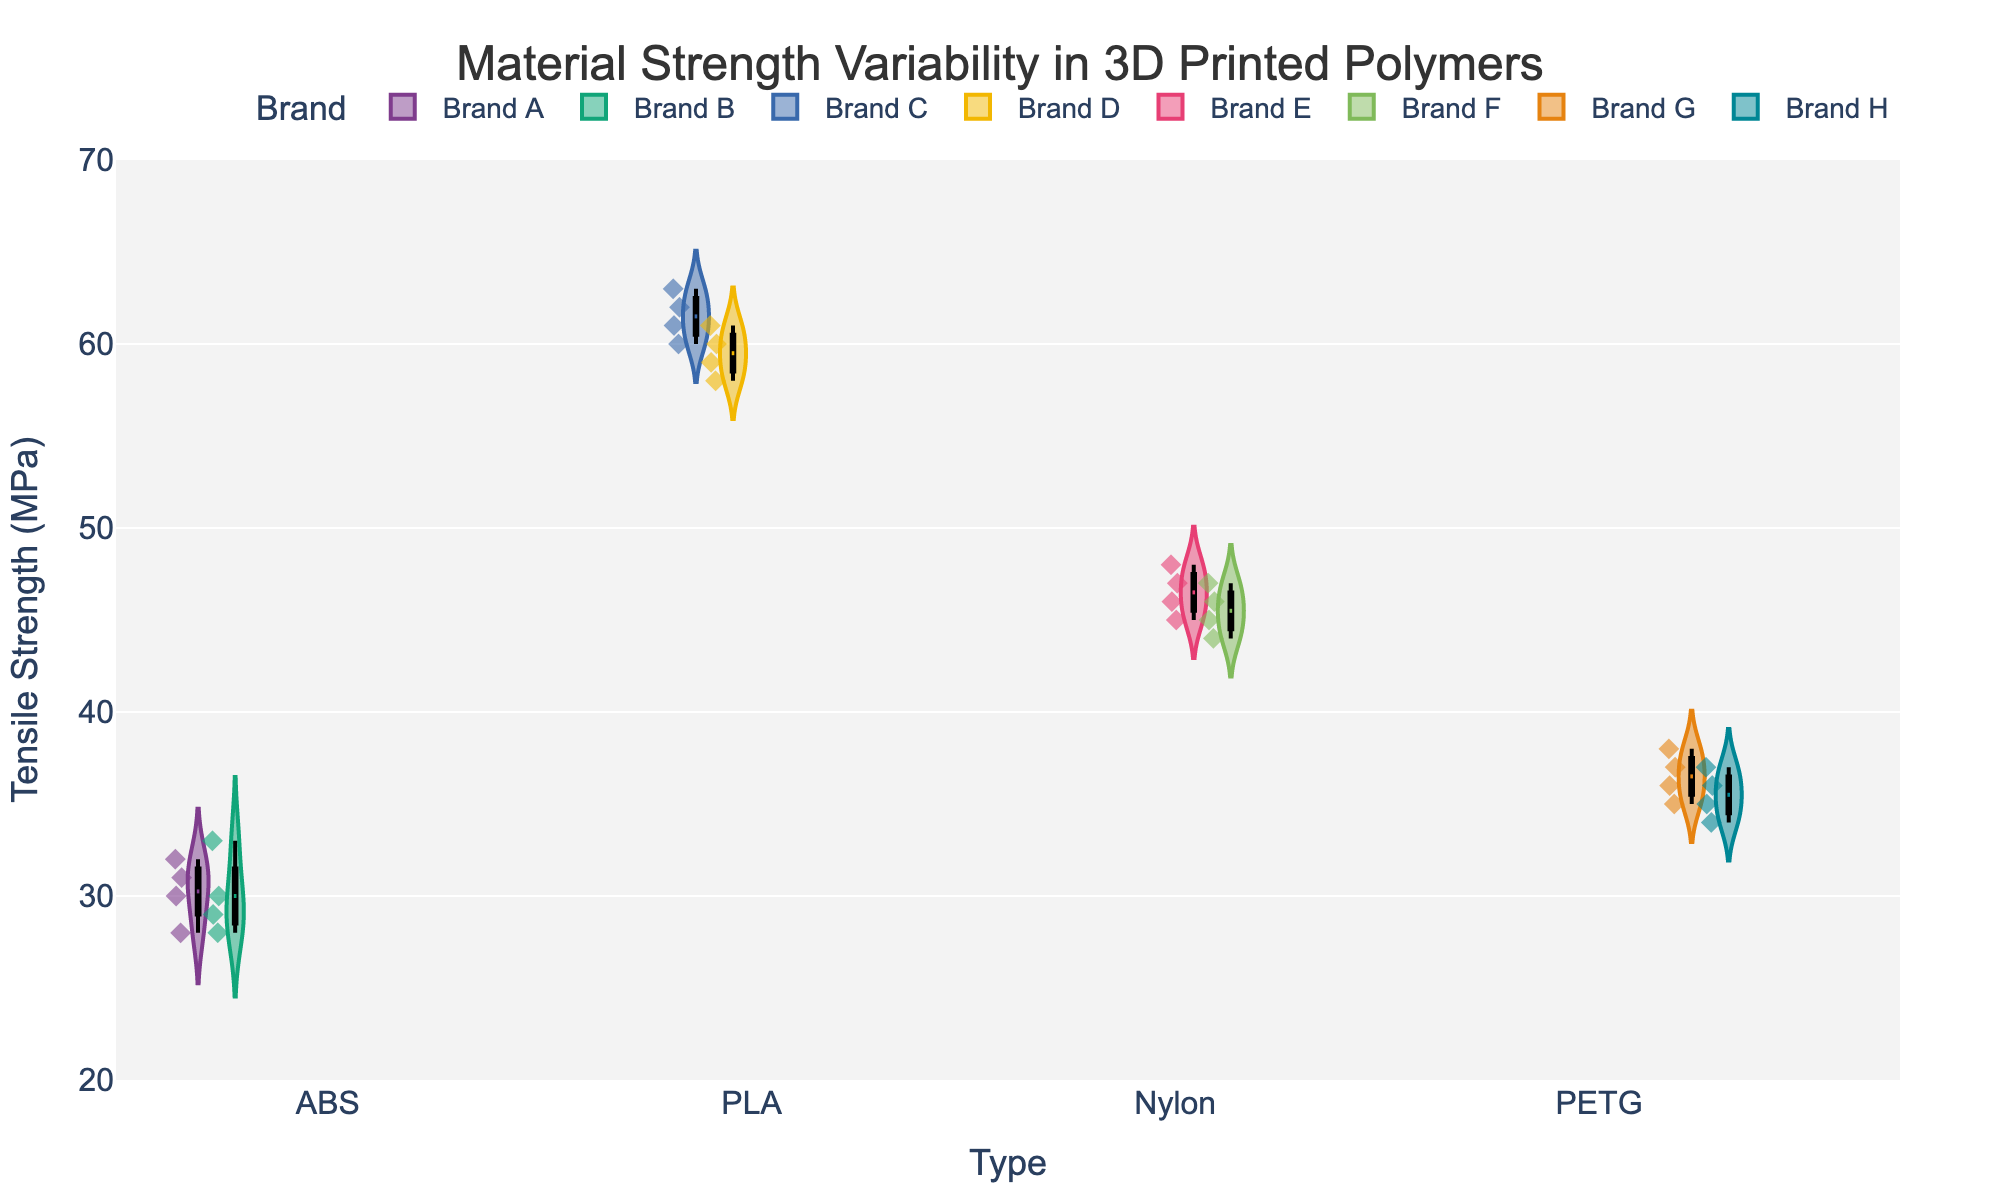What type of polymers are being compared in the violin plot? The x-axis of the violin plot shows the types of polymers being compared: ABS, PLA, Nylon, and PETG.
Answer: ABS, PLA, Nylon, PETG Which polymer type shows the highest range of tensile strength? By looking at the spread of the violins, PLA has the highest range of tensile strength values from 58 to 63 MPa.
Answer: PLA What are the minimum and maximum tensile strengths observed for PETG? The box plot within the PETG violin plot shows the minimum at 34 MPa and the maximum at 38 MPa.
Answer: 34 MPa, 38 MPa Which material has brands that show overlapping tensile strength values? By comparing the distribution, ABS's Brand A and Brand B have strengths that overlap between roughly 28 to 33 MPa.
Answer: ABS Which polymer shows the least variability in tensile strength? The violin for PLA has the narrowest spread, indicating the lowest variability in tensile strength.
Answer: PLA Are the mean tensile strengths for PLA and Nylon polymer types the same? The mean lines in the violin plots for PLA and Nylon show different positions, PLA around 60 MPa, and Nylon around 46 MPa.
Answer: No What's the difference between the median tensile strengths of PLA and ABS? The median for PLA is around 61 MPa, and for ABS, it is around 30 MPa. The difference is 61 - 30 = 31 MPa.
Answer: 31 MPa Which polymer type has the highest interquartile range (IQR) in tensile strength? Visually checking the box widths, ABS has a wider IQR spanning from 28 to 32 MPa, implying it's higher than the others.
Answer: ABS Between PETG and Nylon, which has higher maximum tensile strength? By comparing the upper end of the violin plots, Nylon's maximum of 48 MPa is higher than PETG's maximum of 38 MPa.
Answer: Nylon What does the mean line in the violin plot indicate about material strength distribution? The mean line represents the average tensile strength for each polymer type, showing the central tendency of the data within each group.
Answer: Average tensile strength 